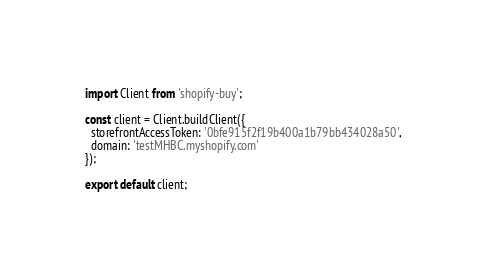<code> <loc_0><loc_0><loc_500><loc_500><_JavaScript_>import Client from 'shopify-buy';

const client = Client.buildClient({
  storefrontAccessToken: '0bfe915f2f19b400a1b79bb434028a50',
  domain: 'testMHBC.myshopify.com'
});

export default client;</code> 